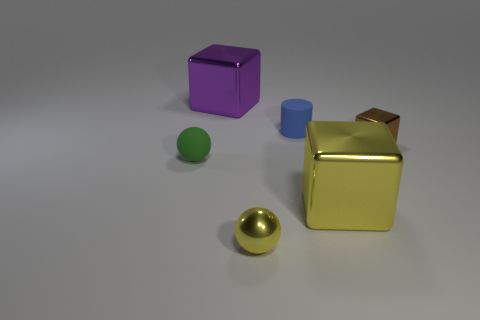Subtract all big blocks. How many blocks are left? 1 Add 1 blue rubber spheres. How many objects exist? 7 Subtract all purple cubes. How many cubes are left? 2 Subtract all cylinders. How many objects are left? 5 Subtract 1 balls. How many balls are left? 1 Add 2 tiny shiny cubes. How many tiny shiny cubes exist? 3 Subtract 0 gray spheres. How many objects are left? 6 Subtract all gray spheres. Subtract all green blocks. How many spheres are left? 2 Subtract all large yellow shiny things. Subtract all big purple rubber objects. How many objects are left? 5 Add 3 big yellow blocks. How many big yellow blocks are left? 4 